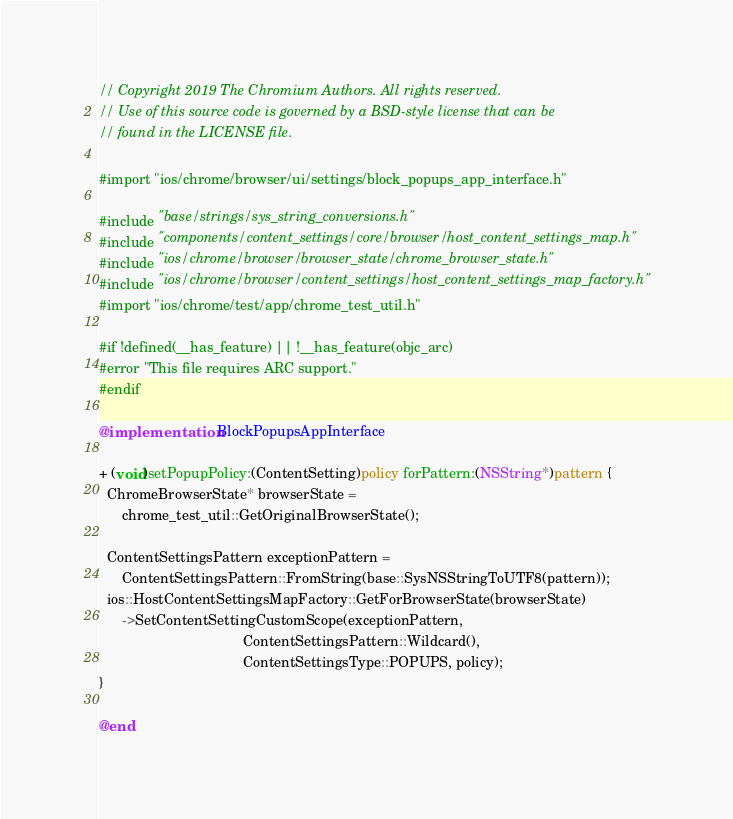<code> <loc_0><loc_0><loc_500><loc_500><_ObjectiveC_>// Copyright 2019 The Chromium Authors. All rights reserved.
// Use of this source code is governed by a BSD-style license that can be
// found in the LICENSE file.

#import "ios/chrome/browser/ui/settings/block_popups_app_interface.h"

#include "base/strings/sys_string_conversions.h"
#include "components/content_settings/core/browser/host_content_settings_map.h"
#include "ios/chrome/browser/browser_state/chrome_browser_state.h"
#include "ios/chrome/browser/content_settings/host_content_settings_map_factory.h"
#import "ios/chrome/test/app/chrome_test_util.h"

#if !defined(__has_feature) || !__has_feature(objc_arc)
#error "This file requires ARC support."
#endif

@implementation BlockPopupsAppInterface

+ (void)setPopupPolicy:(ContentSetting)policy forPattern:(NSString*)pattern {
  ChromeBrowserState* browserState =
      chrome_test_util::GetOriginalBrowserState();

  ContentSettingsPattern exceptionPattern =
      ContentSettingsPattern::FromString(base::SysNSStringToUTF8(pattern));
  ios::HostContentSettingsMapFactory::GetForBrowserState(browserState)
      ->SetContentSettingCustomScope(exceptionPattern,
                                     ContentSettingsPattern::Wildcard(),
                                     ContentSettingsType::POPUPS, policy);
}

@end
</code> 